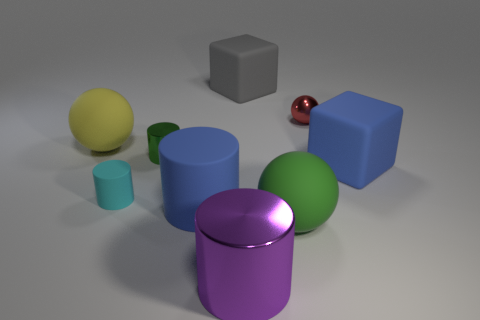Subtract all green cylinders. How many cylinders are left? 3 Subtract all small green cylinders. How many cylinders are left? 3 Add 1 large objects. How many objects exist? 10 Subtract all brown cylinders. Subtract all brown cubes. How many cylinders are left? 4 Subtract all blocks. How many objects are left? 7 Add 6 big purple things. How many big purple things are left? 7 Add 1 tiny blue cubes. How many tiny blue cubes exist? 1 Subtract 0 green cubes. How many objects are left? 9 Subtract all big purple shiny cylinders. Subtract all large matte objects. How many objects are left? 3 